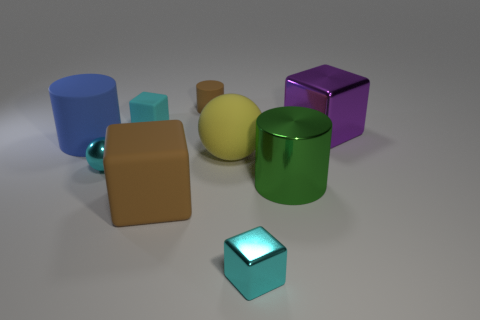There is a cyan block that is made of the same material as the yellow ball; what size is it?
Provide a succinct answer. Small. There is a cyan thing that is behind the big blue cylinder; how many large rubber cylinders are behind it?
Give a very brief answer. 0. Is the material of the green thing that is in front of the large yellow rubber object the same as the big blue cylinder?
Offer a very short reply. No. Is there anything else that has the same material as the yellow object?
Provide a succinct answer. Yes. How big is the cyan block that is left of the small cube that is in front of the cyan sphere?
Your answer should be very brief. Small. There is a cyan cube that is to the right of the tiny matte thing in front of the object that is behind the tiny cyan rubber cube; what size is it?
Your answer should be compact. Small. There is a brown thing that is in front of the small cyan ball; is its shape the same as the brown object behind the large blue matte cylinder?
Provide a succinct answer. No. How many other objects are there of the same color as the metal sphere?
Keep it short and to the point. 2. There is a rubber cylinder on the left side of the cyan rubber cube; does it have the same size as the big brown rubber thing?
Keep it short and to the point. Yes. Are the tiny sphere that is in front of the big yellow ball and the big green thing to the right of the brown matte block made of the same material?
Offer a terse response. Yes. 